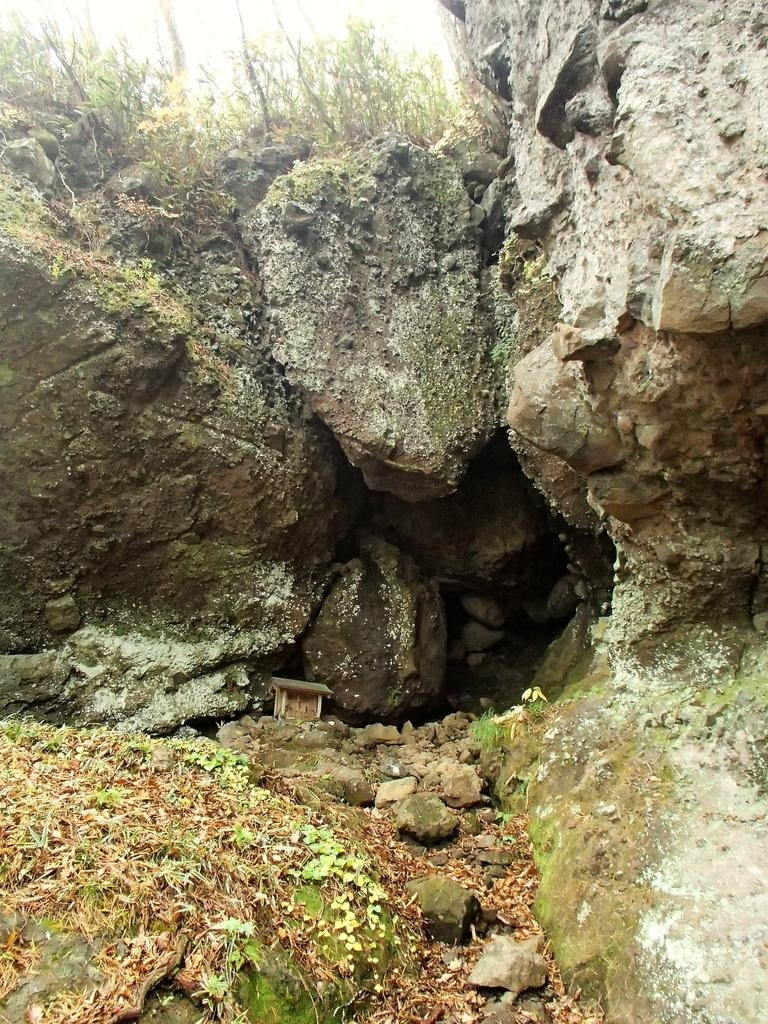What type of natural material can be seen in the image? There are dried leaves in the image. What is growing on the rocks in the image? There is algae formation on rocks in the image. What type of vegetation is present in the image? There are plants in the image. What type of club is being used to generate income in the image? There is no club or mention of income generation in the image; it features dried leaves, algae formation on rocks, and plants. 